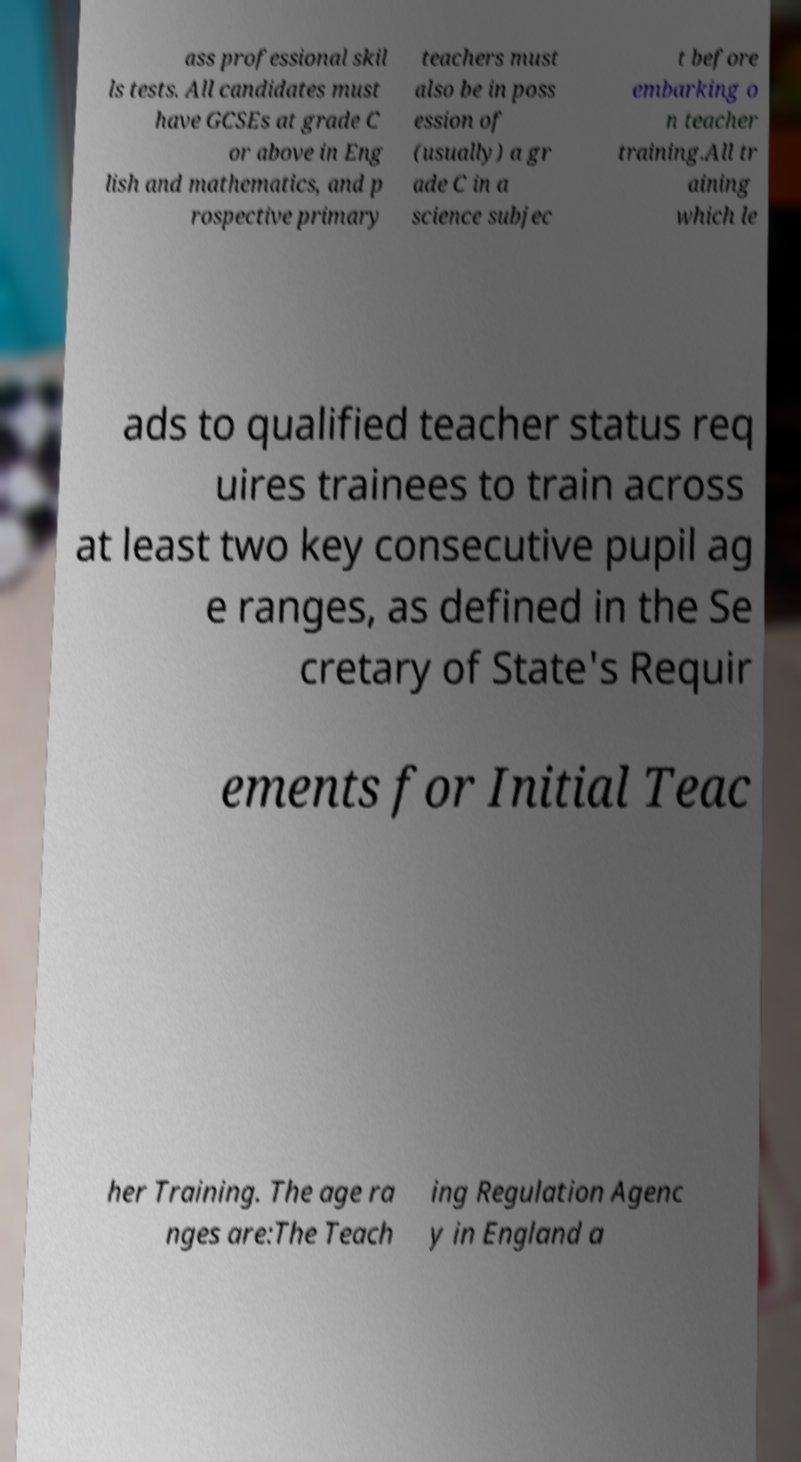What messages or text are displayed in this image? I need them in a readable, typed format. ass professional skil ls tests. All candidates must have GCSEs at grade C or above in Eng lish and mathematics, and p rospective primary teachers must also be in poss ession of (usually) a gr ade C in a science subjec t before embarking o n teacher training.All tr aining which le ads to qualified teacher status req uires trainees to train across at least two key consecutive pupil ag e ranges, as defined in the Se cretary of State's Requir ements for Initial Teac her Training. The age ra nges are:The Teach ing Regulation Agenc y in England a 